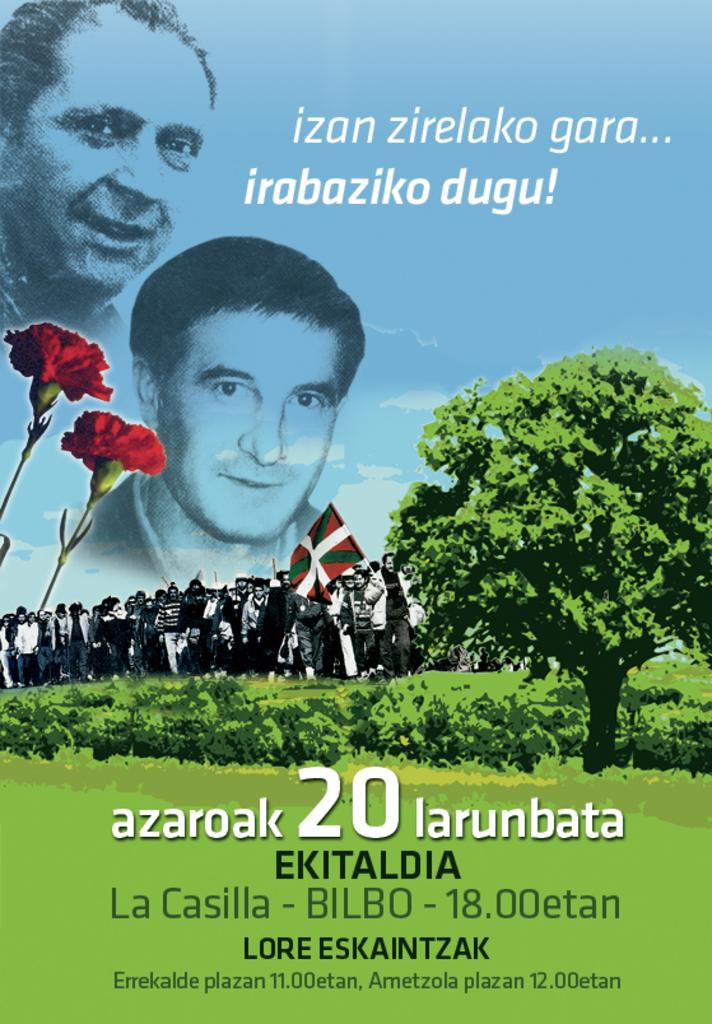<image>
Give a short and clear explanation of the subsequent image. A sign displays two men and La Casilla. 